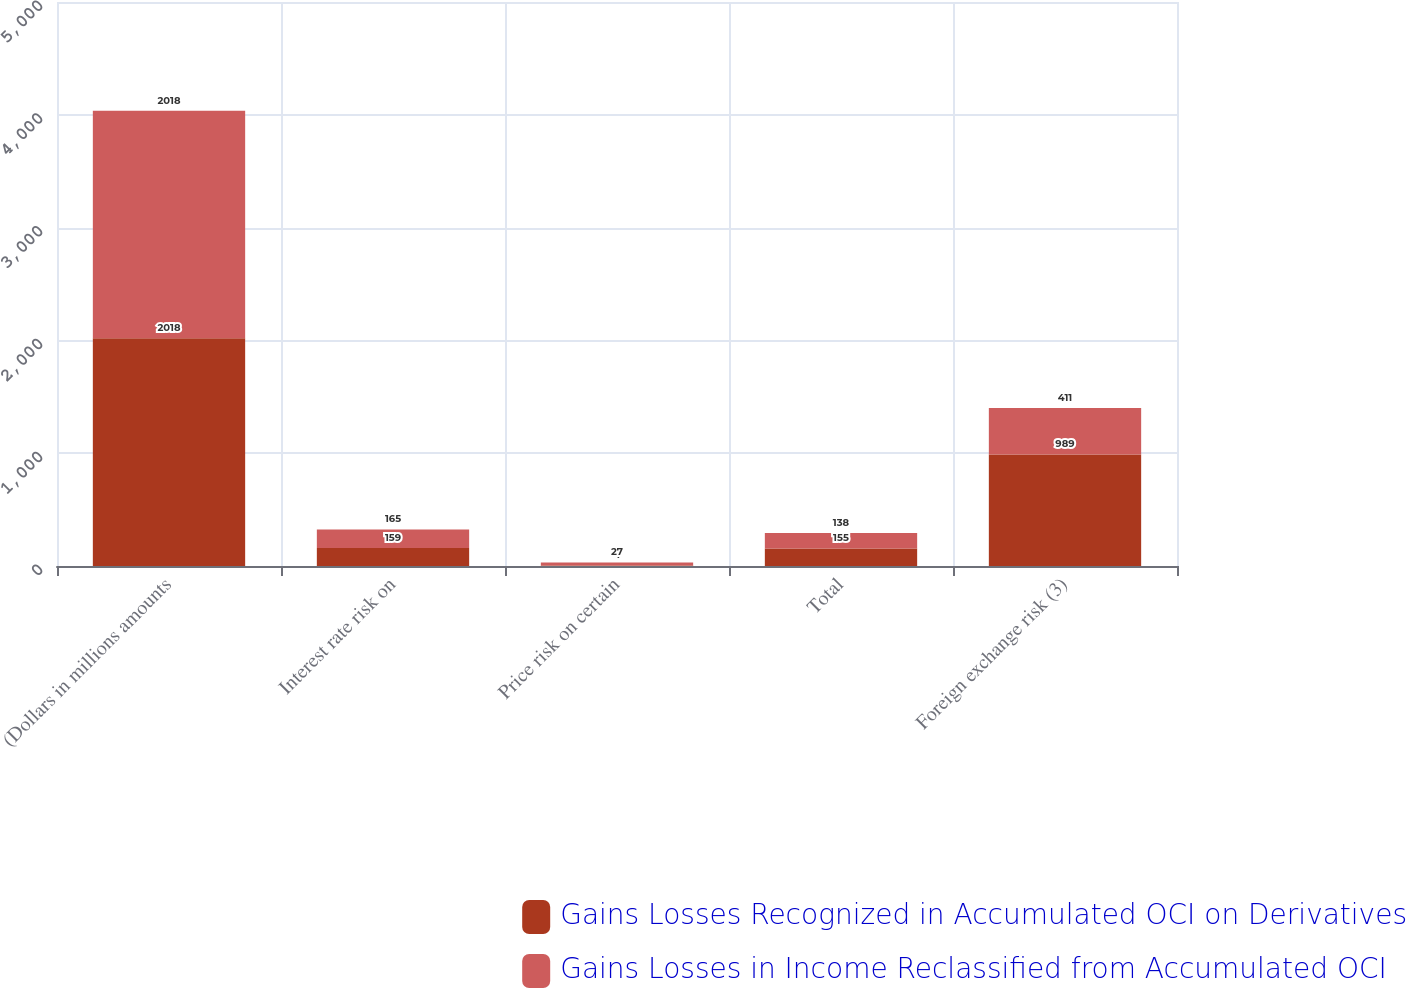Convert chart to OTSL. <chart><loc_0><loc_0><loc_500><loc_500><stacked_bar_chart><ecel><fcel>(Dollars in millions amounts<fcel>Interest rate risk on<fcel>Price risk on certain<fcel>Total<fcel>Foreign exchange risk (3)<nl><fcel>Gains Losses Recognized in Accumulated OCI on Derivatives<fcel>2018<fcel>159<fcel>4<fcel>155<fcel>989<nl><fcel>Gains Losses in Income Reclassified from Accumulated OCI<fcel>2018<fcel>165<fcel>27<fcel>138<fcel>411<nl></chart> 